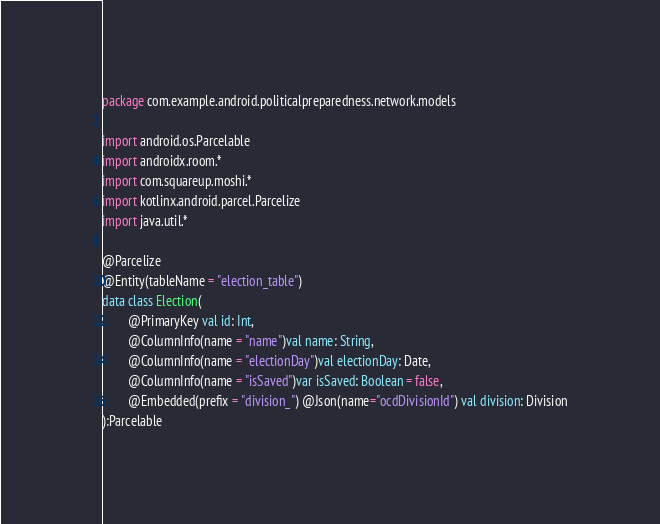<code> <loc_0><loc_0><loc_500><loc_500><_Kotlin_>package com.example.android.politicalpreparedness.network.models

import android.os.Parcelable
import androidx.room.*
import com.squareup.moshi.*
import kotlinx.android.parcel.Parcelize
import java.util.*

@Parcelize
@Entity(tableName = "election_table")
data class Election(
        @PrimaryKey val id: Int,
        @ColumnInfo(name = "name")val name: String,
        @ColumnInfo(name = "electionDay")val electionDay: Date,
        @ColumnInfo(name = "isSaved")var isSaved: Boolean = false,
        @Embedded(prefix = "division_") @Json(name="ocdDivisionId") val division: Division
):Parcelable</code> 